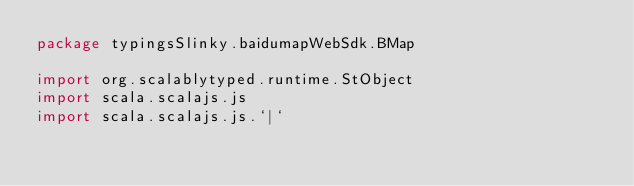<code> <loc_0><loc_0><loc_500><loc_500><_Scala_>package typingsSlinky.baidumapWebSdk.BMap

import org.scalablytyped.runtime.StObject
import scala.scalajs.js
import scala.scalajs.js.`|`</code> 